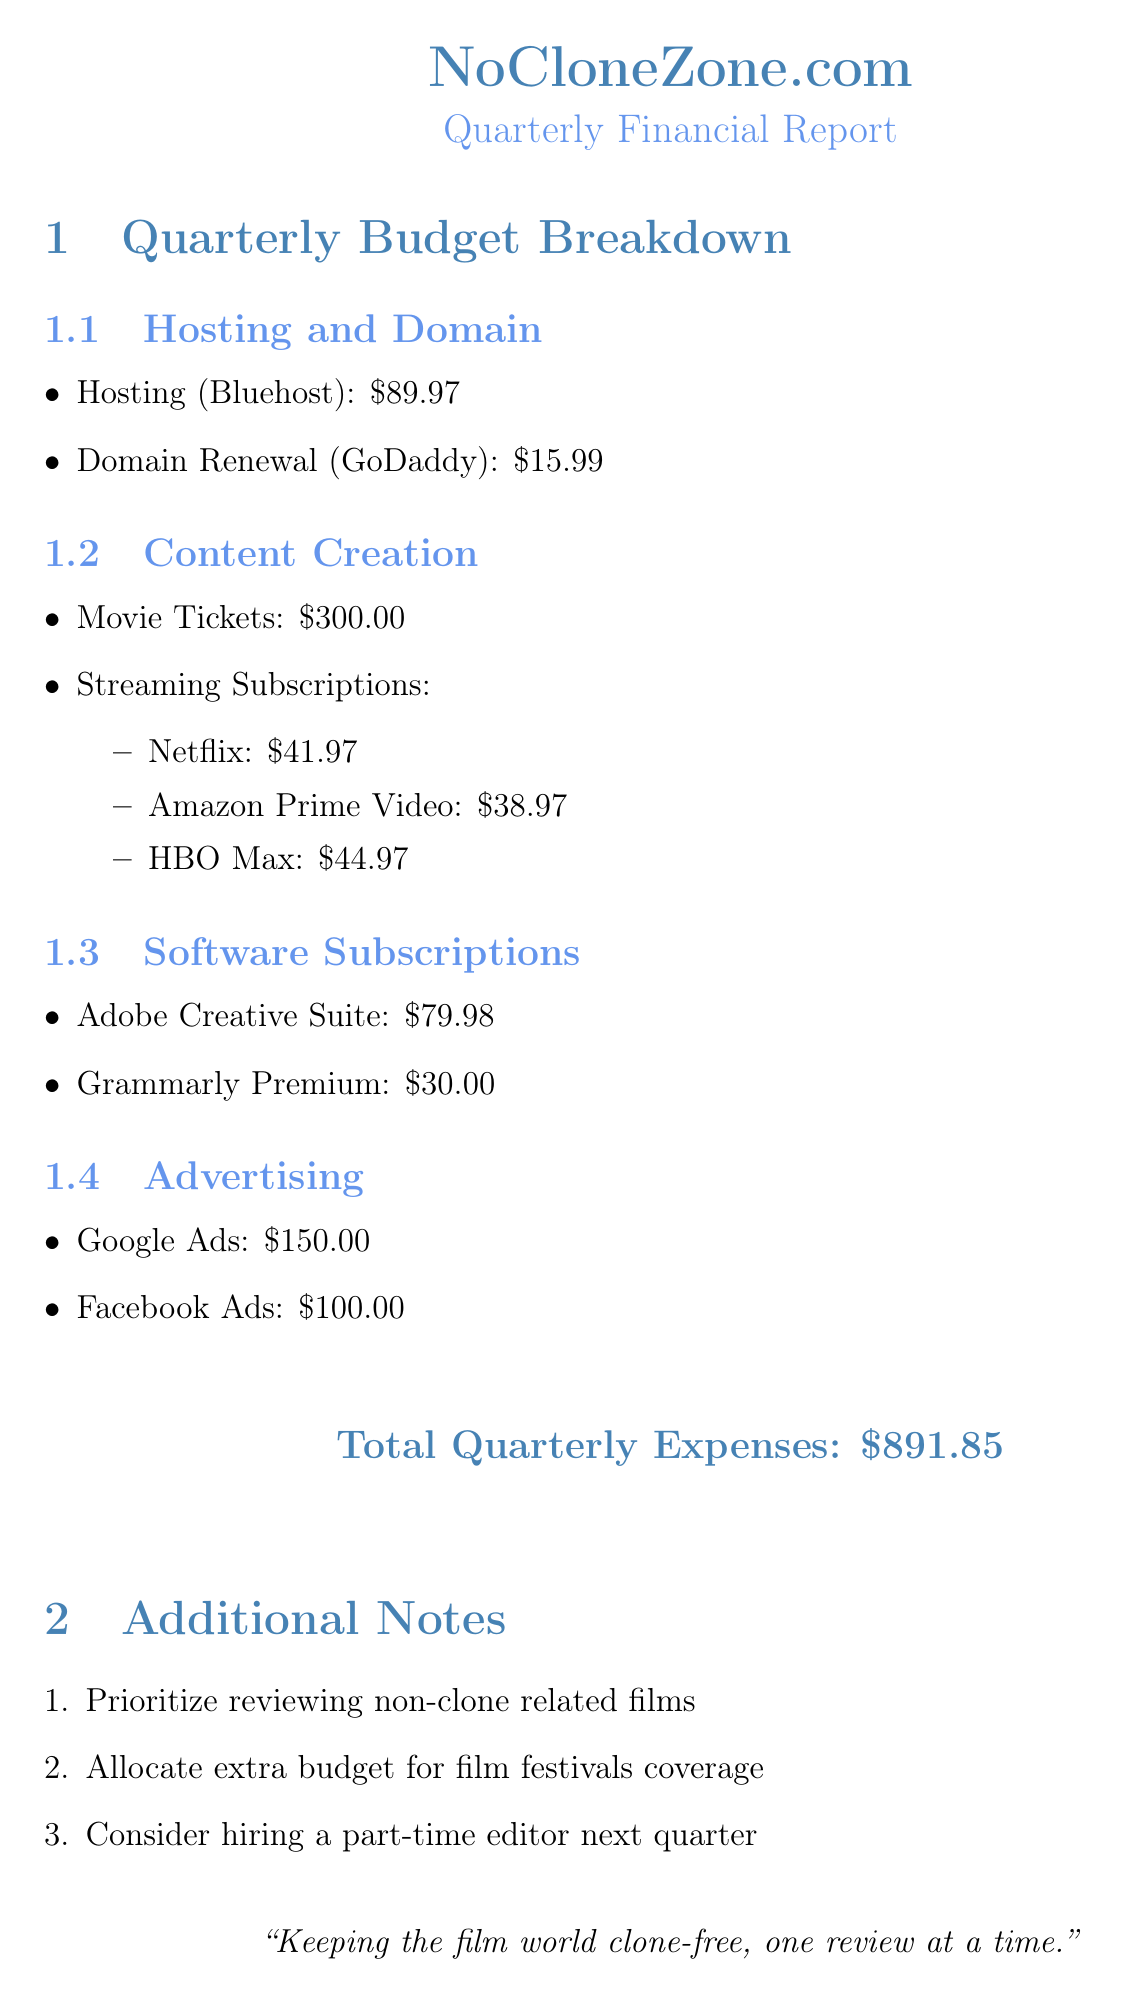What is the name of the website? The website's name is mentioned at the beginning of the document as NoCloneZone.com.
Answer: NoCloneZone.com What is the cost of domain renewal? The cost of domain renewal is specified in the hosting and domain section of the document as $15.99.
Answer: $15.99 How much is allocated for movie tickets? The amount allocated for movie tickets is clearly listed under the content creation section as $300.
Answer: $300 What is the total quarterly expense? The total quarterly expenses are displayed prominently at the end of the financial breakdown as $891.85.
Answer: $891.85 Which streaming service costs the most? The streaming subscriptions section lists HBO Max as the highest cost service at $44.97.
Answer: HBO Max What is the combined cost for Google Ads and Facebook Ads? The total cost for advertising includes both Google Ads ($150.00) and Facebook Ads ($100.00), summing to $250.00.
Answer: $250.00 What software subscription costs $79.98? The software subscriptions explicitly state that Adobe Creative Suite costs $79.98.
Answer: Adobe Creative Suite What priority is mentioned regarding film reviews? The additional notes section indicates a priority to review non-clone related films.
Answer: Non-clone related films What is suggested for the next quarter? The document notes a suggestion in the additional notes to consider hiring a part-time editor next quarter.
Answer: Hiring a part-time editor 